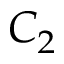<formula> <loc_0><loc_0><loc_500><loc_500>C _ { 2 }</formula> 